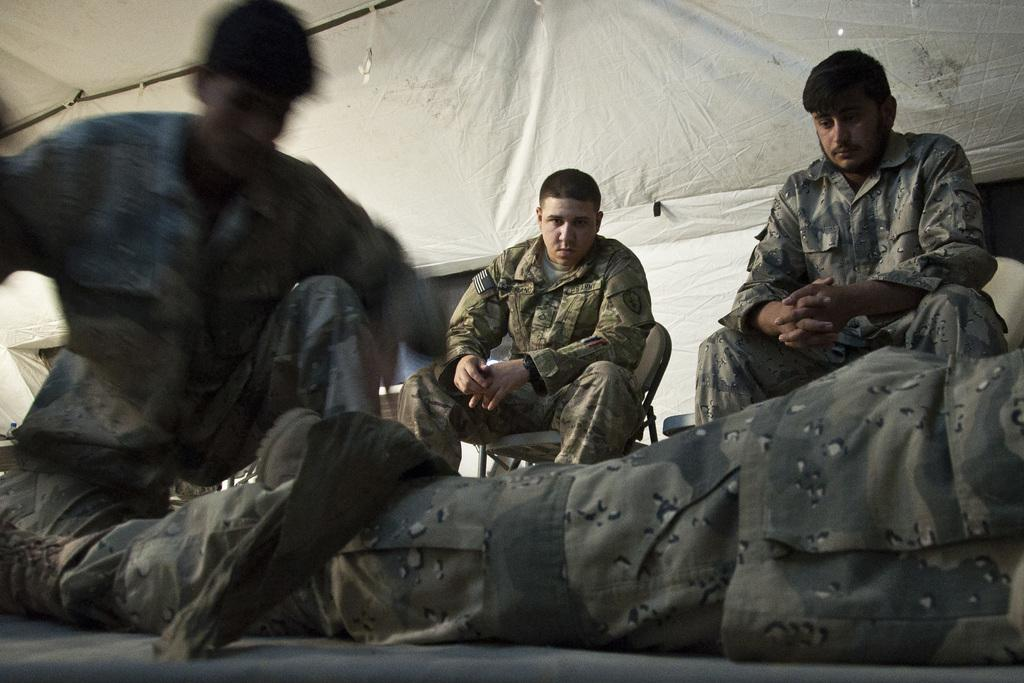What are the people in the image doing? There are persons sitting on chairs in the image. Can you describe the position of the man in the image? There is a man lying on the ground in the image. What can be seen in the background of the image? There is a tent in the background of the image. What type of food is the cook preparing in the image? There is no cook or food preparation visible in the image. What sense is being stimulated by the persons sitting on chairs in the image? The provided facts do not mention any sensory experiences, so it is not possible to determine which sense is being stimulated. 